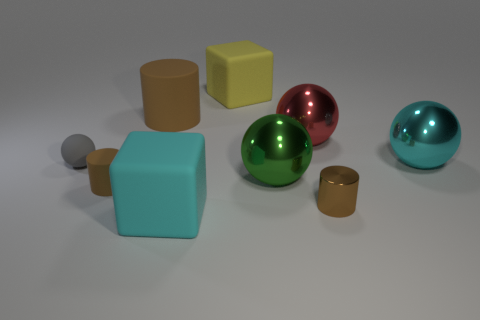What could be the purpose of this assortment of items? This appears to be a rendered scene, possibly created to showcase different textures and lighting effects on various geometric shapes. Such an assortment is commonly used in 3D modeling and computer graphics to demonstrate rendering capabilities or to practice lighting and texturing techniques. 